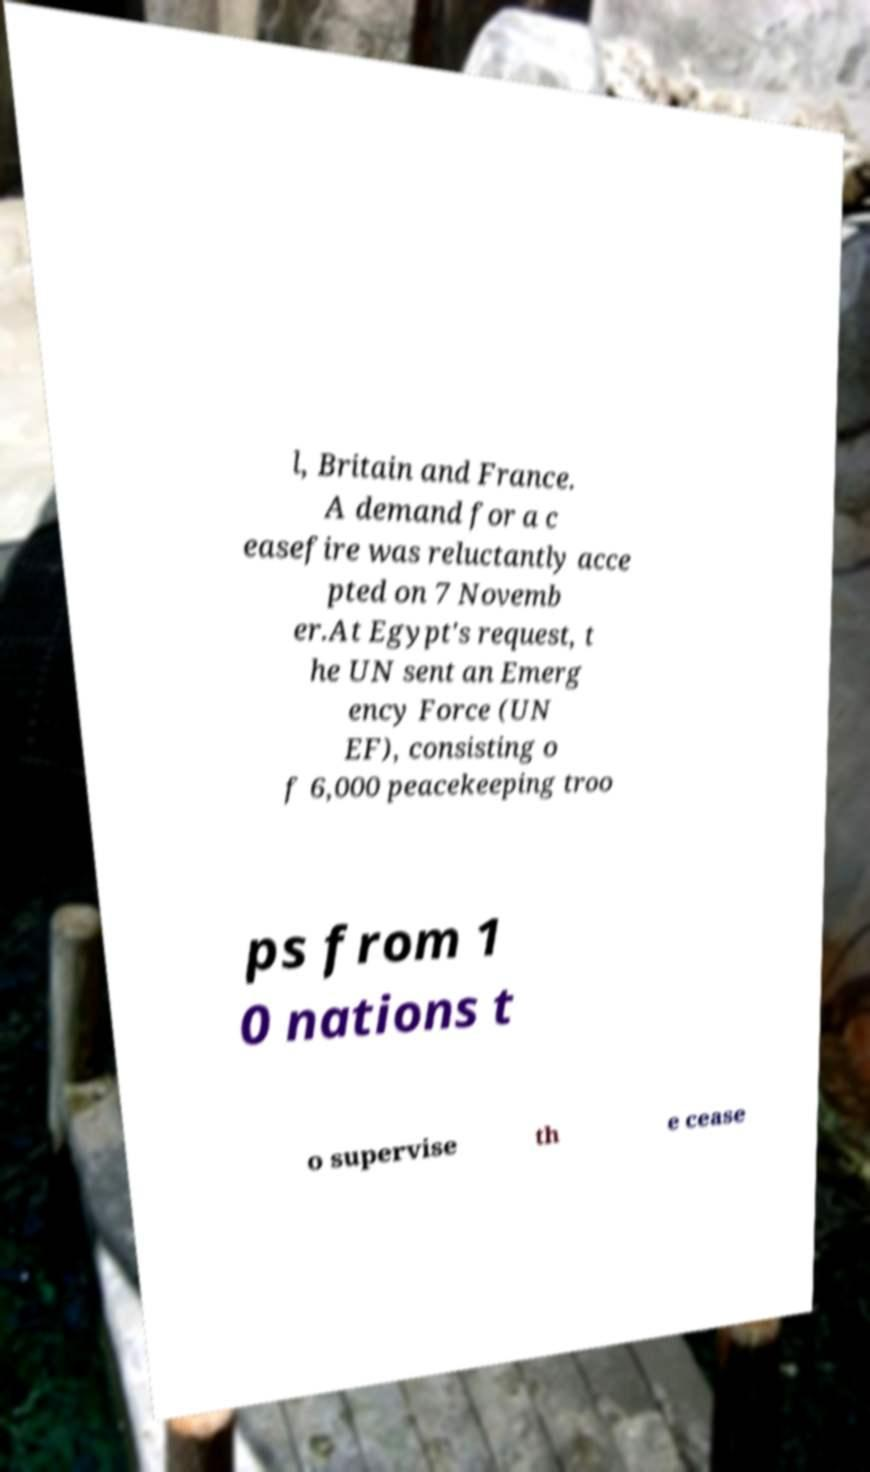Please identify and transcribe the text found in this image. l, Britain and France. A demand for a c easefire was reluctantly acce pted on 7 Novemb er.At Egypt's request, t he UN sent an Emerg ency Force (UN EF), consisting o f 6,000 peacekeeping troo ps from 1 0 nations t o supervise th e cease 